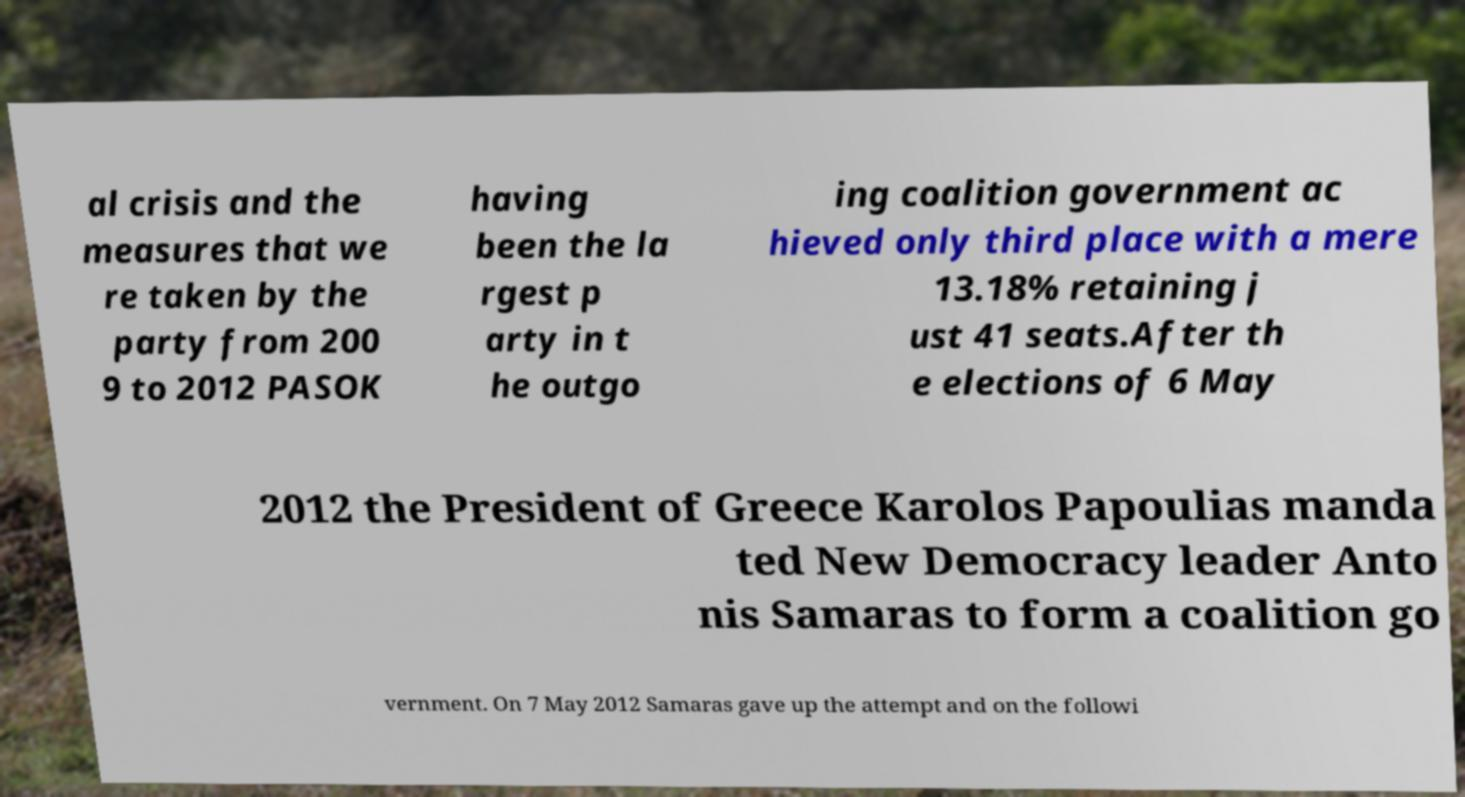Could you assist in decoding the text presented in this image and type it out clearly? al crisis and the measures that we re taken by the party from 200 9 to 2012 PASOK having been the la rgest p arty in t he outgo ing coalition government ac hieved only third place with a mere 13.18% retaining j ust 41 seats.After th e elections of 6 May 2012 the President of Greece Karolos Papoulias manda ted New Democracy leader Anto nis Samaras to form a coalition go vernment. On 7 May 2012 Samaras gave up the attempt and on the followi 